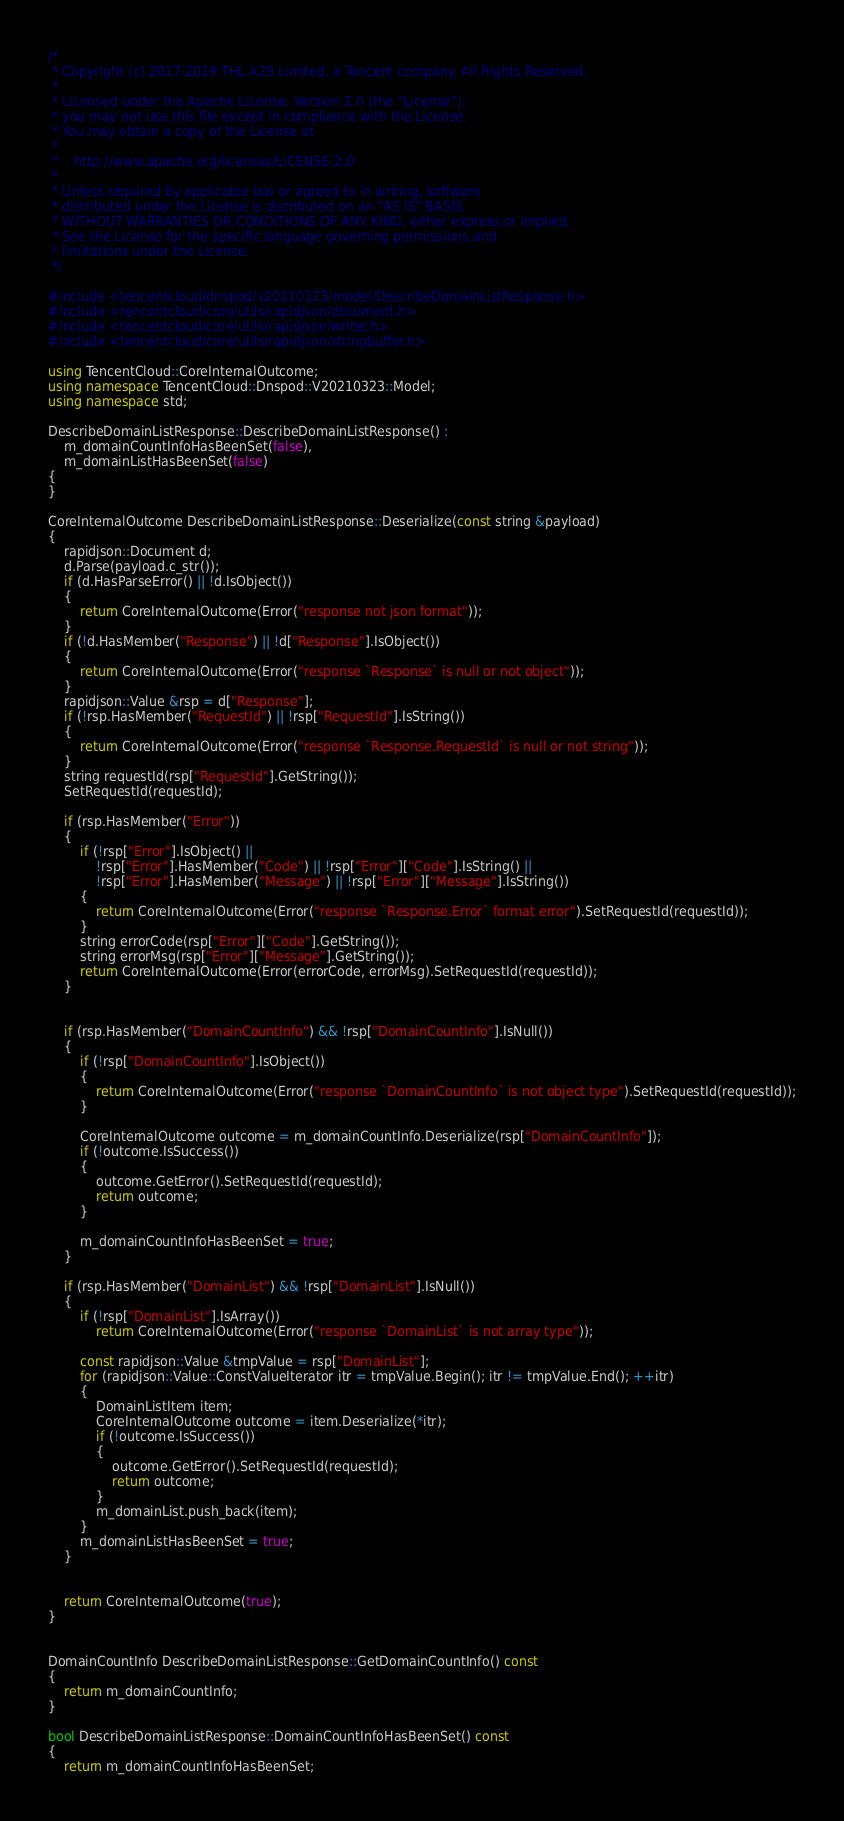<code> <loc_0><loc_0><loc_500><loc_500><_C++_>/*
 * Copyright (c) 2017-2019 THL A29 Limited, a Tencent company. All Rights Reserved.
 *
 * Licensed under the Apache License, Version 2.0 (the "License");
 * you may not use this file except in compliance with the License.
 * You may obtain a copy of the License at
 *
 *    http://www.apache.org/licenses/LICENSE-2.0
 *
 * Unless required by applicable law or agreed to in writing, software
 * distributed under the License is distributed on an "AS IS" BASIS,
 * WITHOUT WARRANTIES OR CONDITIONS OF ANY KIND, either express or implied.
 * See the License for the specific language governing permissions and
 * limitations under the License.
 */

#include <tencentcloud/dnspod/v20210323/model/DescribeDomainListResponse.h>
#include <tencentcloud/core/utils/rapidjson/document.h>
#include <tencentcloud/core/utils/rapidjson/writer.h>
#include <tencentcloud/core/utils/rapidjson/stringbuffer.h>

using TencentCloud::CoreInternalOutcome;
using namespace TencentCloud::Dnspod::V20210323::Model;
using namespace std;

DescribeDomainListResponse::DescribeDomainListResponse() :
    m_domainCountInfoHasBeenSet(false),
    m_domainListHasBeenSet(false)
{
}

CoreInternalOutcome DescribeDomainListResponse::Deserialize(const string &payload)
{
    rapidjson::Document d;
    d.Parse(payload.c_str());
    if (d.HasParseError() || !d.IsObject())
    {
        return CoreInternalOutcome(Error("response not json format"));
    }
    if (!d.HasMember("Response") || !d["Response"].IsObject())
    {
        return CoreInternalOutcome(Error("response `Response` is null or not object"));
    }
    rapidjson::Value &rsp = d["Response"];
    if (!rsp.HasMember("RequestId") || !rsp["RequestId"].IsString())
    {
        return CoreInternalOutcome(Error("response `Response.RequestId` is null or not string"));
    }
    string requestId(rsp["RequestId"].GetString());
    SetRequestId(requestId);

    if (rsp.HasMember("Error"))
    {
        if (!rsp["Error"].IsObject() ||
            !rsp["Error"].HasMember("Code") || !rsp["Error"]["Code"].IsString() ||
            !rsp["Error"].HasMember("Message") || !rsp["Error"]["Message"].IsString())
        {
            return CoreInternalOutcome(Error("response `Response.Error` format error").SetRequestId(requestId));
        }
        string errorCode(rsp["Error"]["Code"].GetString());
        string errorMsg(rsp["Error"]["Message"].GetString());
        return CoreInternalOutcome(Error(errorCode, errorMsg).SetRequestId(requestId));
    }


    if (rsp.HasMember("DomainCountInfo") && !rsp["DomainCountInfo"].IsNull())
    {
        if (!rsp["DomainCountInfo"].IsObject())
        {
            return CoreInternalOutcome(Error("response `DomainCountInfo` is not object type").SetRequestId(requestId));
        }

        CoreInternalOutcome outcome = m_domainCountInfo.Deserialize(rsp["DomainCountInfo"]);
        if (!outcome.IsSuccess())
        {
            outcome.GetError().SetRequestId(requestId);
            return outcome;
        }

        m_domainCountInfoHasBeenSet = true;
    }

    if (rsp.HasMember("DomainList") && !rsp["DomainList"].IsNull())
    {
        if (!rsp["DomainList"].IsArray())
            return CoreInternalOutcome(Error("response `DomainList` is not array type"));

        const rapidjson::Value &tmpValue = rsp["DomainList"];
        for (rapidjson::Value::ConstValueIterator itr = tmpValue.Begin(); itr != tmpValue.End(); ++itr)
        {
            DomainListItem item;
            CoreInternalOutcome outcome = item.Deserialize(*itr);
            if (!outcome.IsSuccess())
            {
                outcome.GetError().SetRequestId(requestId);
                return outcome;
            }
            m_domainList.push_back(item);
        }
        m_domainListHasBeenSet = true;
    }


    return CoreInternalOutcome(true);
}


DomainCountInfo DescribeDomainListResponse::GetDomainCountInfo() const
{
    return m_domainCountInfo;
}

bool DescribeDomainListResponse::DomainCountInfoHasBeenSet() const
{
    return m_domainCountInfoHasBeenSet;</code> 